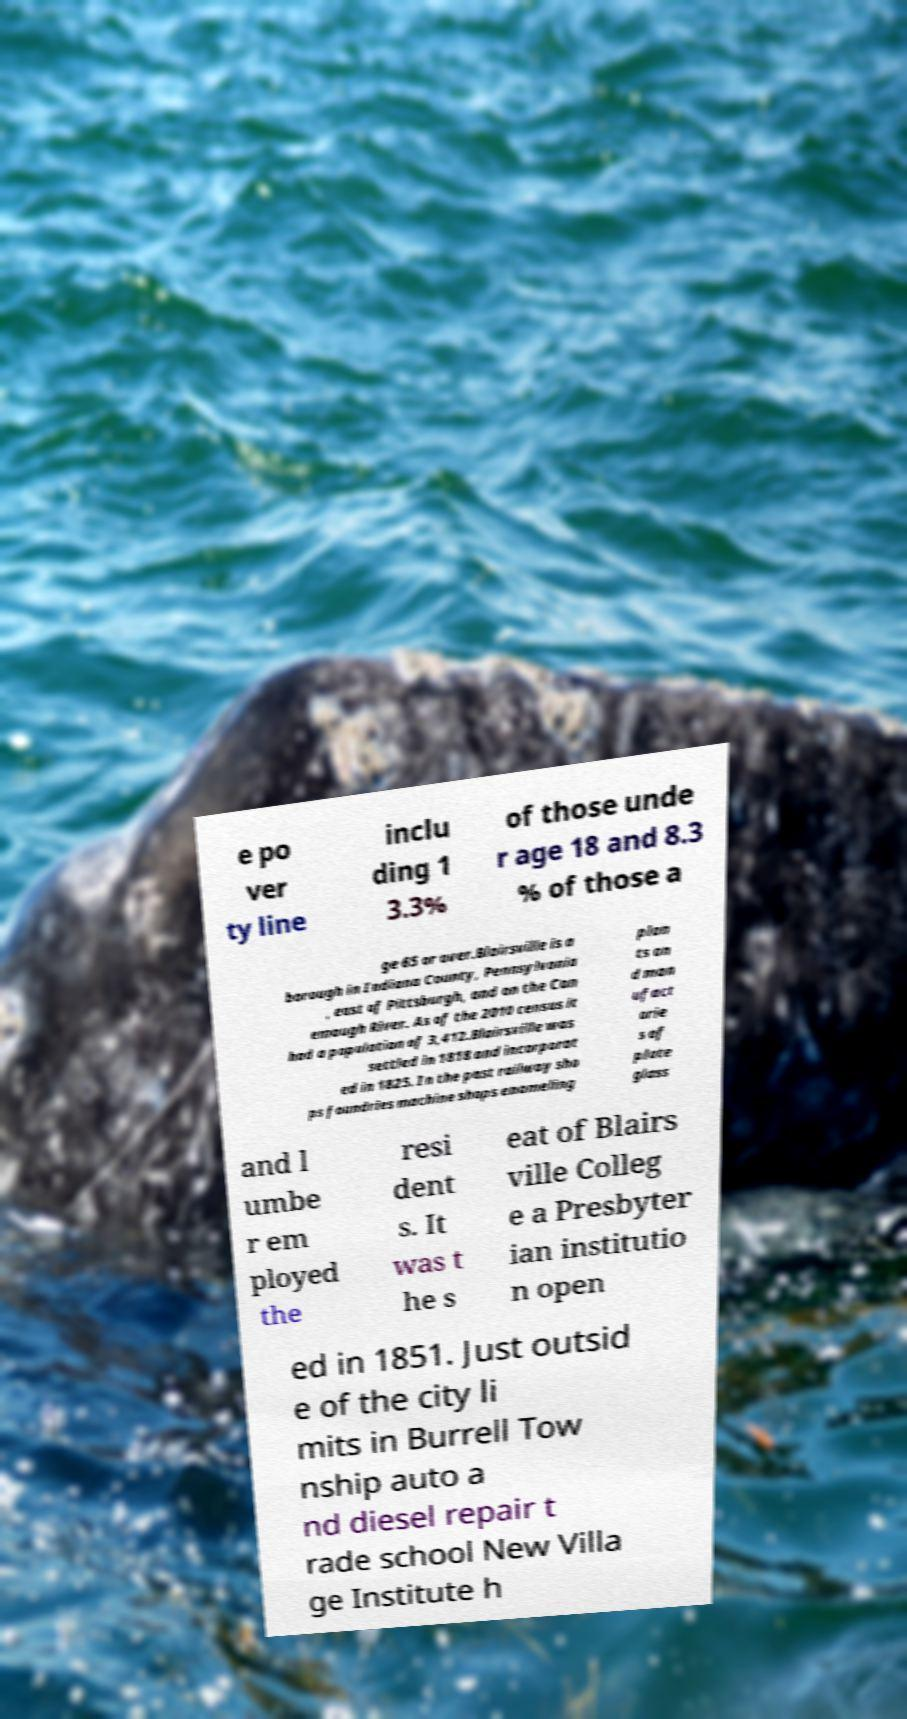I need the written content from this picture converted into text. Can you do that? e po ver ty line inclu ding 1 3.3% of those unde r age 18 and 8.3 % of those a ge 65 or over.Blairsville is a borough in Indiana County, Pennsylvania , east of Pittsburgh, and on the Con emaugh River. As of the 2010 census it had a population of 3,412.Blairsville was settled in 1818 and incorporat ed in 1825. In the past railway sho ps foundries machine shops enameling plan ts an d man ufact orie s of plate glass and l umbe r em ployed the resi dent s. It was t he s eat of Blairs ville Colleg e a Presbyter ian institutio n open ed in 1851. Just outsid e of the city li mits in Burrell Tow nship auto a nd diesel repair t rade school New Villa ge Institute h 